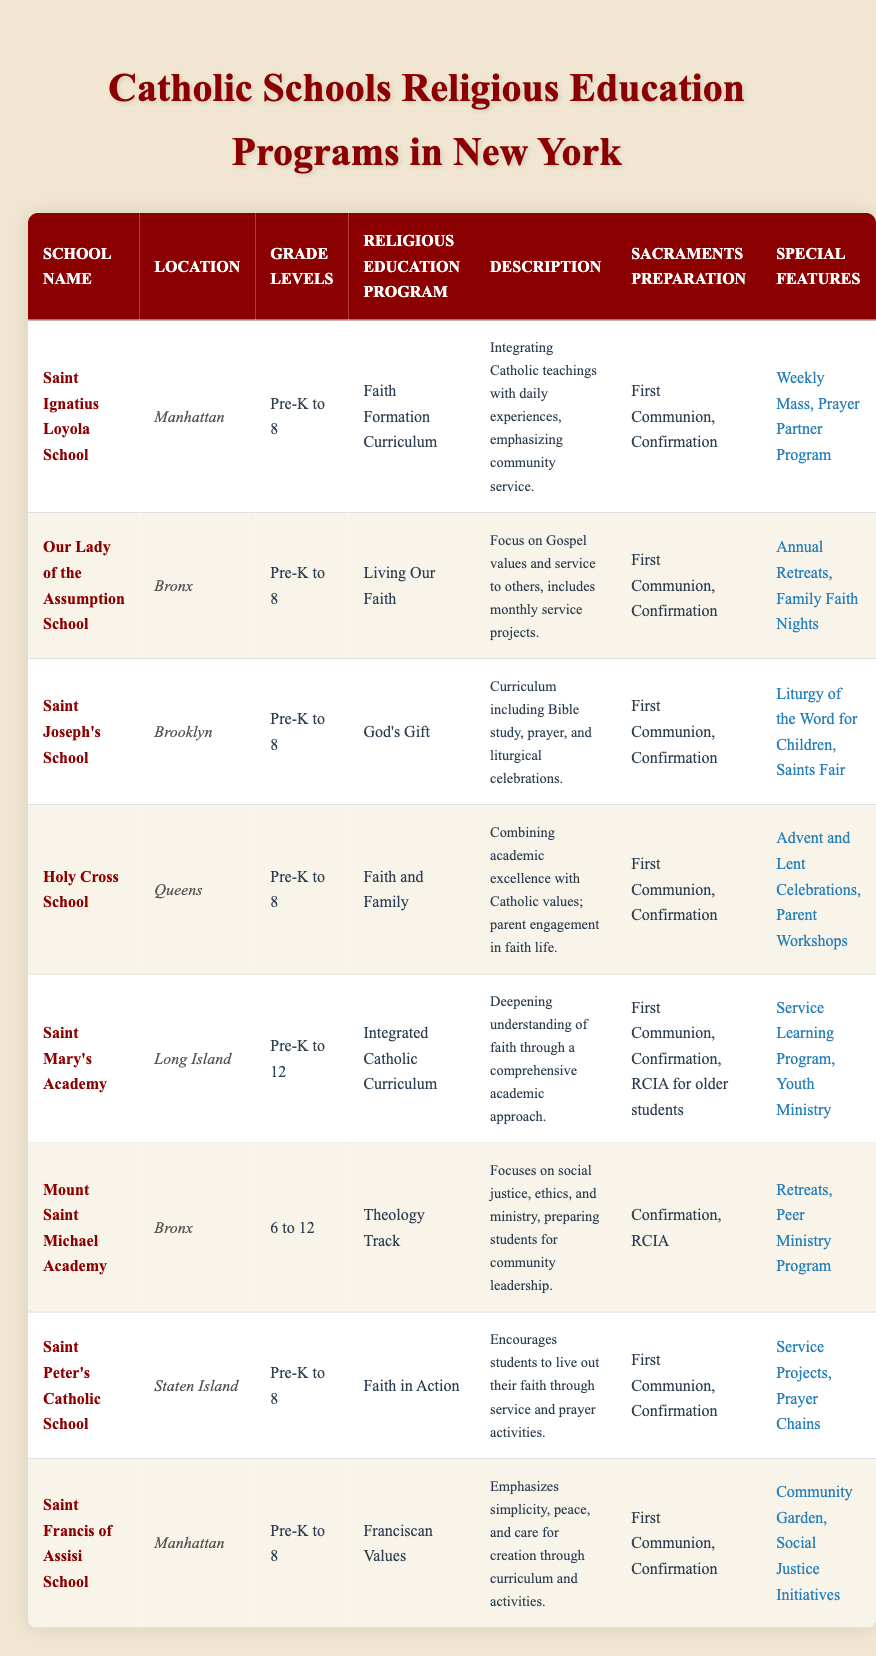What religious education program is offered by Saint Joseph's School? From the table, under the "Religious Education Program" column, the entry for "Saint Joseph's School" shows it offers the "God's Gift" program.
Answer: God's Gift Which school located in Queens combines academic excellence with Catholic values? Referring to the "Description" section, "Holy Cross School" in Queens emphasizes combining academic excellence with Catholic values.
Answer: Holy Cross School How many schools offer preparation for First Communion and Confirmation? From the table, I will count the schools that mention "First Communion, Confirmation" under "Sacraments Preparation". That includes Saint Ignatius Loyola School, Our Lady of the Assumption School, Saint Joseph's School, Holy Cross School, Saint Peter's Catholic School, and Saint Francis of Assisi School. In total, there are 6 schools.
Answer: 6 Does Saint Mary's Academy provide a program for older students seeking RCIA? Checking the "Sacraments Preparation" for "Saint Mary's Academy," it mentions "RCIA for older students," which confirms that yes, it does provide this program.
Answer: Yes Which school's students participate in a Community Garden as part of their special features? The "Special Features" section for "Saint Francis of Assisi School" mentions a "Community Garden." Therefore, this school includes it as part of their program.
Answer: Saint Francis of Assisi School What is the average grade level range for the schools listed? The grade levels differ: Saint Ignatius Loyola School (Pre-K to 8), Our Lady of the Assumption School (Pre-K to 8), Saint Joseph's School (Pre-K to 8), Holy Cross School (Pre-K to 8), Saint Mary's Academy (Pre-K to 12), Mount Saint Michael Academy (6 to 12), Saint Peter's Catholic School (Pre-K to 8), and Saint Francis of Assisi School (Pre-K to 8). To calculate the average, converting grade levels into numbers gives ranges with minimum of Pre-K and maximum of 12. The average range accounts to about Pre-K to 8.73 (approx. 9).
Answer: Pre-K to 9 Which location has the highest number of schools mentioned in the table? By checking the "Location" column, I see that both the Bronx and Manhattan each have 3 schools listed (Our Lady of the Assumption School, Mount Saint Michael Academy, and the other schools associated with these locations). Thus, both areas are tied.
Answer: Bronx and Manhattan Do all of the schools listed prepare students for the same sacraments? Reviewing the "Sacraments Preparation" column, it is evident that all schools listed prepare for "First Communion" and "Confirmation." Therefore, the answer is yes.
Answer: Yes 